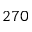Convert formula to latex. <formula><loc_0><loc_0><loc_500><loc_500>2 7 0</formula> 